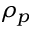<formula> <loc_0><loc_0><loc_500><loc_500>\rho _ { p }</formula> 